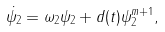<formula> <loc_0><loc_0><loc_500><loc_500>\dot { \psi _ { 2 } } = \omega _ { 2 } \psi _ { 2 } + d ( t ) \psi _ { 2 } ^ { m + 1 } ,</formula> 